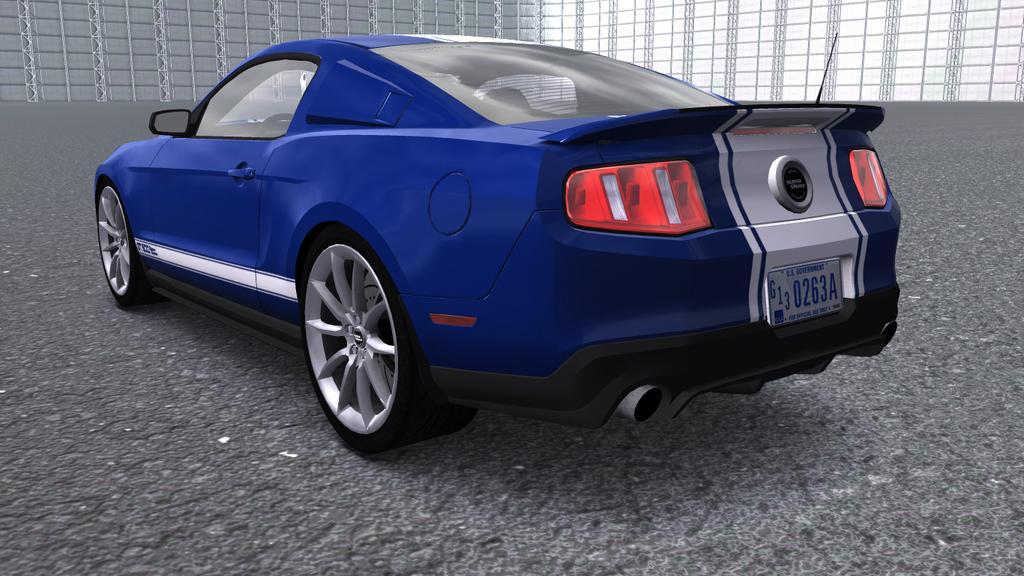Describe this image in one or two sentences. In this picture we can see the edited image the blue color car parked on the road. Behind we can see the frame wall. 